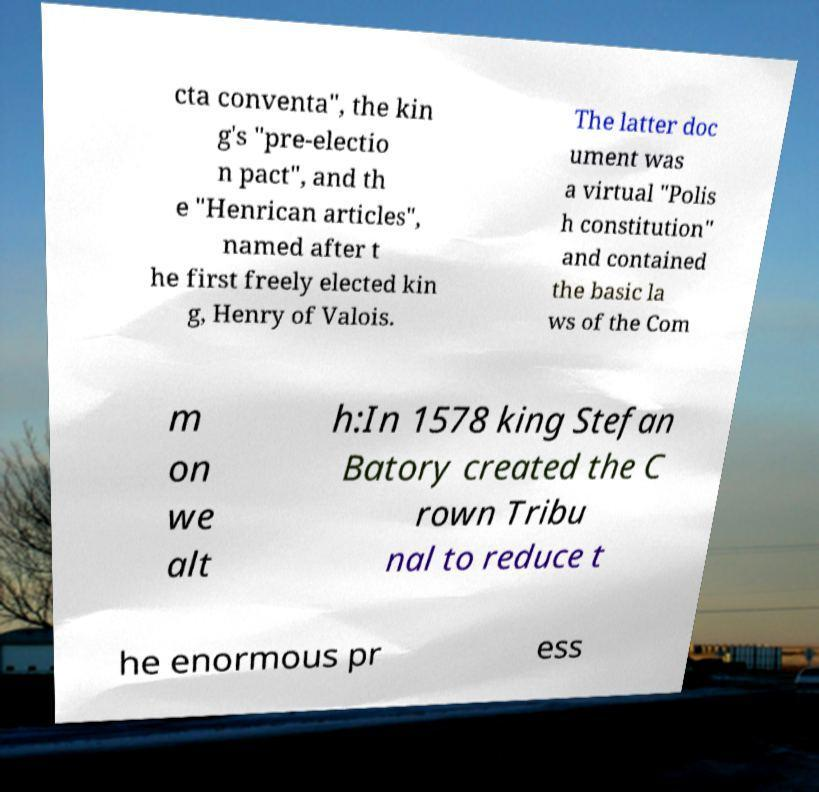What messages or text are displayed in this image? I need them in a readable, typed format. cta conventa", the kin g's "pre-electio n pact", and th e "Henrican articles", named after t he first freely elected kin g, Henry of Valois. The latter doc ument was a virtual "Polis h constitution" and contained the basic la ws of the Com m on we alt h:In 1578 king Stefan Batory created the C rown Tribu nal to reduce t he enormous pr ess 